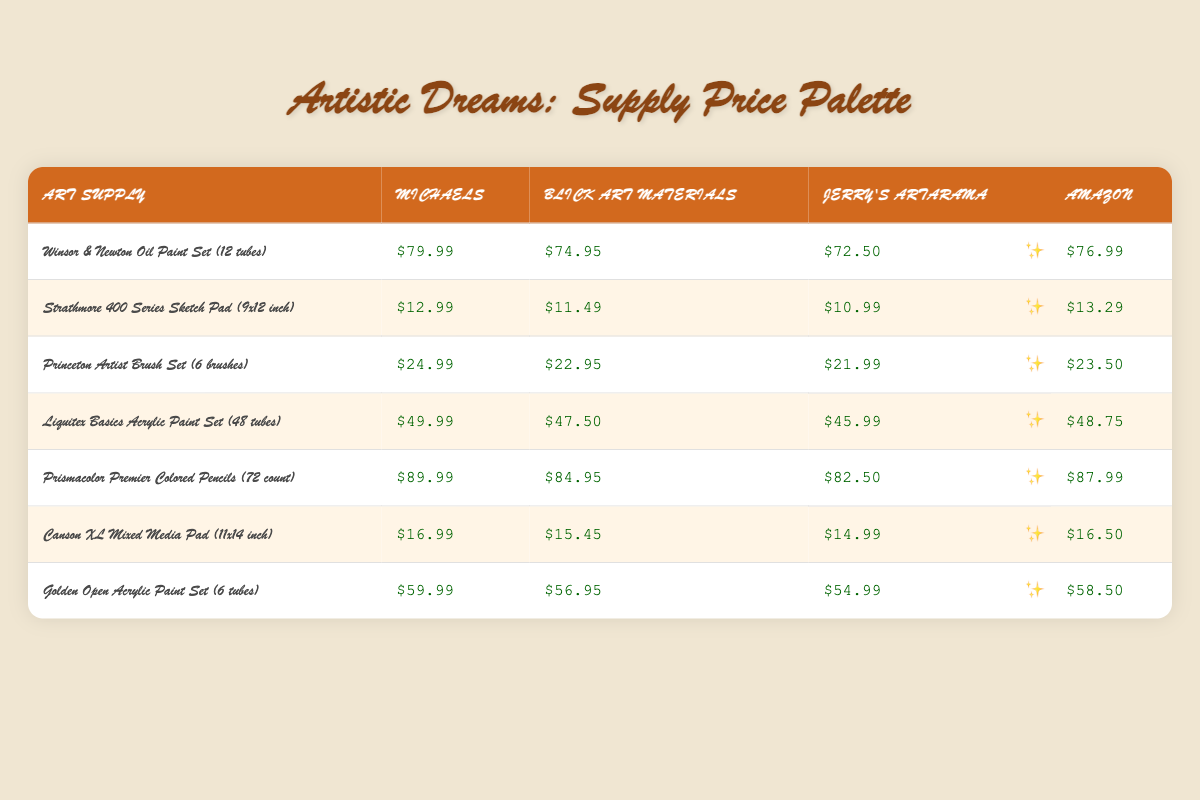What is the lowest price for the Winsor & Newton Oil Paint Set? The table shows prices for the Winsor & Newton Oil Paint Set at four stores: Michaels ($79.99), Blick Art Materials ($74.95), Jerry's Artarama ($72.50), and Amazon ($76.99). The lowest price from these values is $72.50 at Jerry's Artarama.
Answer: $72.50 Which store sells the Strathmore 400 Series Sketch Pad for the highest price? The prices for the Strathmore 400 Series Sketch Pad are Michaels ($12.99), Blick Art Materials ($11.49), Jerry's Artarama ($10.99), and Amazon ($13.29). The highest price among these is $13.29 at Amazon.
Answer: $13.29 What is the average price of the Princeton Artist Brush Set among the four stores? The prices are: Michaels ($24.99), Blick Art Materials ($22.95), Jerry's Artarama ($21.99), and Amazon ($23.50). The sum of these prices is $24.99 + $22.95 + $21.99 + $23.50 = $93.43. Dividing this sum by 4 gives the average price: $93.43 / 4 = $23.36.
Answer: $23.36 Is the price of the Liquitex Basics Acrylic Paint Set the same at Blick Art Materials and Amazon? The price for Liquitex Basics Acrylic Paint Set is Blick Art Materials ($47.50) and Amazon ($48.75). Since these two amounts are different, the answer is no, the price is not the same.
Answer: No Which art supply has the largest price difference between the lowest and highest prices? Evaluating the price differences for each product: 
- Winsor & Newton Oil Paint Set: $79.99 - $72.50 = $7.49
- Strathmore 400 Series Sketch Pad: $13.29 - $10.99 = $2.30
- Princeton Artist Brush Set: $24.99 - $21.99 = $3.00
- Liquitex Basics Acrylic Paint Set: $49.99 - $45.99 = $4.00
- Prismacolor Premier Colored Pencils: $89.99 - $82.50 = $7.49
- Canson XL Mixed Media Pad: $16.99 - $14.99 = $2.00
- Golden Open Acrylic Paint Set: $59.99 - $54.99 = $5.00
The largest difference of $7.49 occurs with both the Winsor & Newton Oil Paint Set and Prismacolor Premier Colored Pencils.
Answer: Winsor & Newton Oil Paint Set and Prismacolor Premier Colored Pencils What is the price of the Canson XL Mixed Media Pad at Blick Art Materials? The Canson XL Mixed Media Pad price at Blick Art Materials is listed as $15.45 in the table provided.
Answer: $15.45 